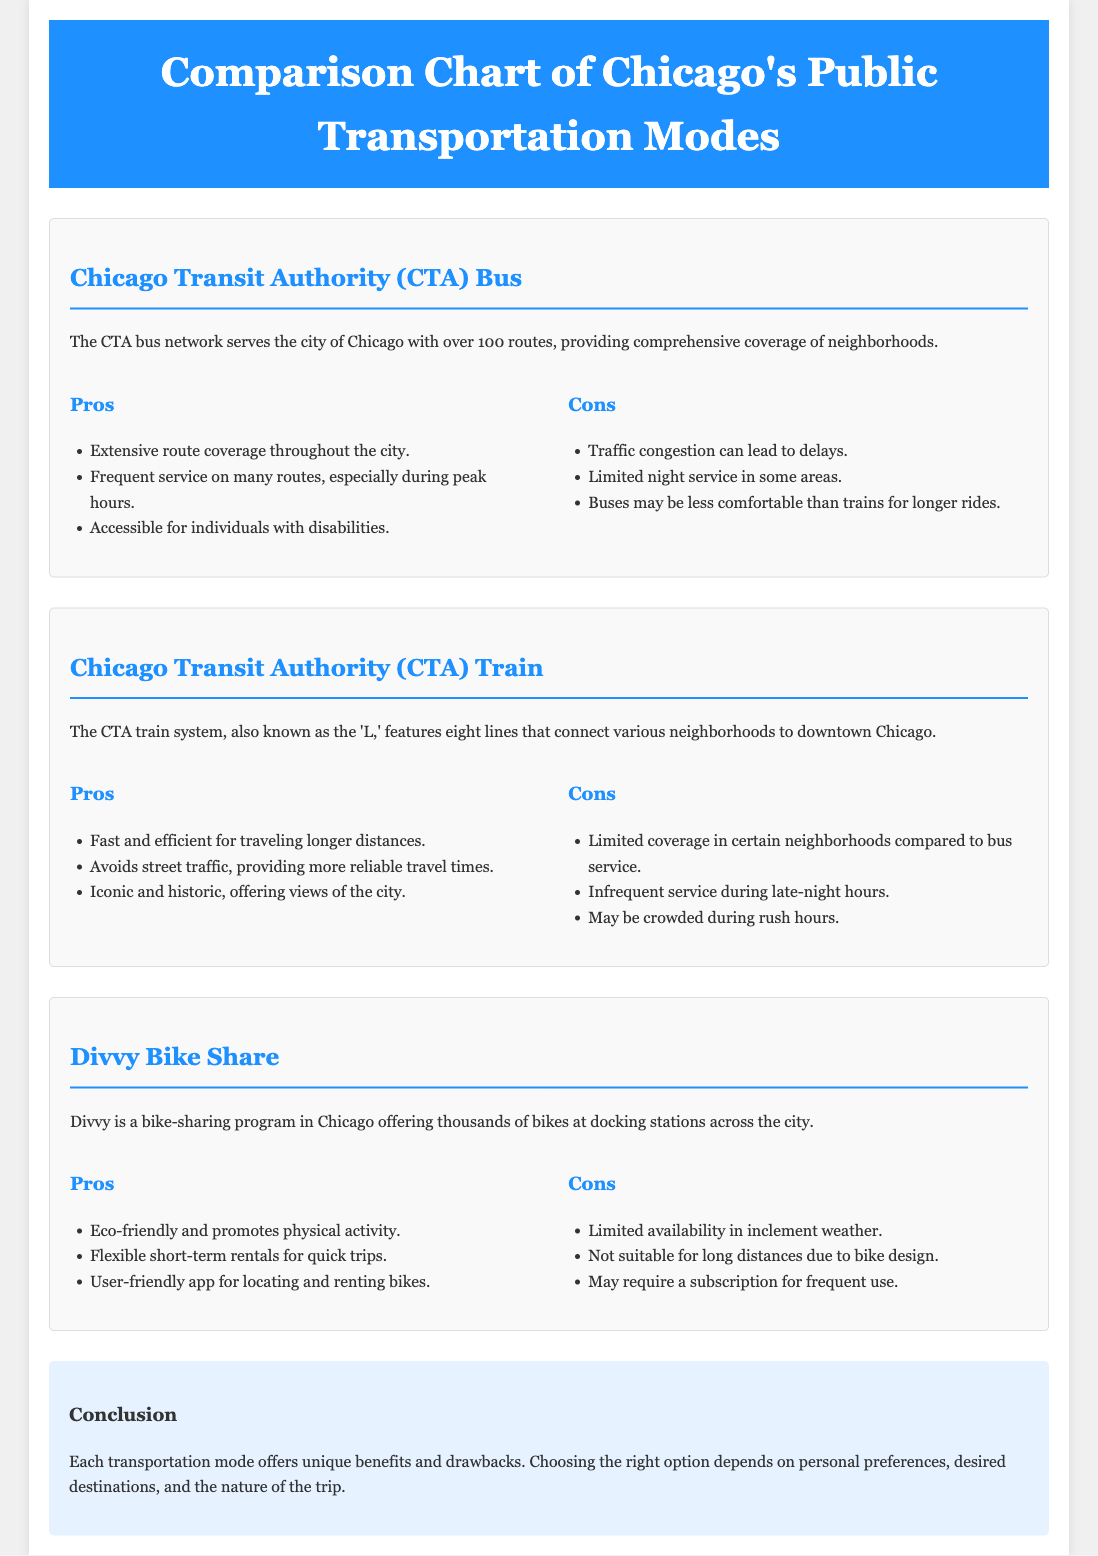What is the total number of CTA bus routes? The document states that the CTA bus network serves with over 100 routes.
Answer: over 100 What is the primary service of the CTA train system? The CTA train system, also known as the 'L,' connects various neighborhoods to downtown Chicago.
Answer: connects neighborhoods to downtown What is the conclusion about Chicago's transportation modes? The conclusion summarizes that each transportation mode offers unique benefits and drawbacks, and the choice depends on personal preferences.
Answer: unique benefits and drawbacks What is one pro of using Divvy bike share? The document mentions that Divvy is eco-friendly and promotes physical activity.
Answer: eco-friendly Which transportation option avoids street traffic? The CTA train system is noted for avoiding street traffic, providing more reliable travel times.
Answer: CTA train system What can cause delays for the CTA bus? Traffic congestion is mentioned as a factor that can lead to delays.
Answer: Traffic congestion How many lines are there in the CTA train system? The document states that the CTA train system features eight lines.
Answer: eight lines What is a disadvantage of Divvy bike share in bad weather? The document specifies that bike availability is limited in inclement weather.
Answer: limited availability During what hours is CTA train service infrequent? The document states that service is infrequent during late-night hours.
Answer: late-night hours 